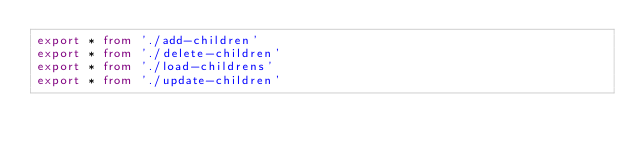Convert code to text. <code><loc_0><loc_0><loc_500><loc_500><_TypeScript_>export * from './add-children'
export * from './delete-children'
export * from './load-childrens'
export * from './update-children'
</code> 